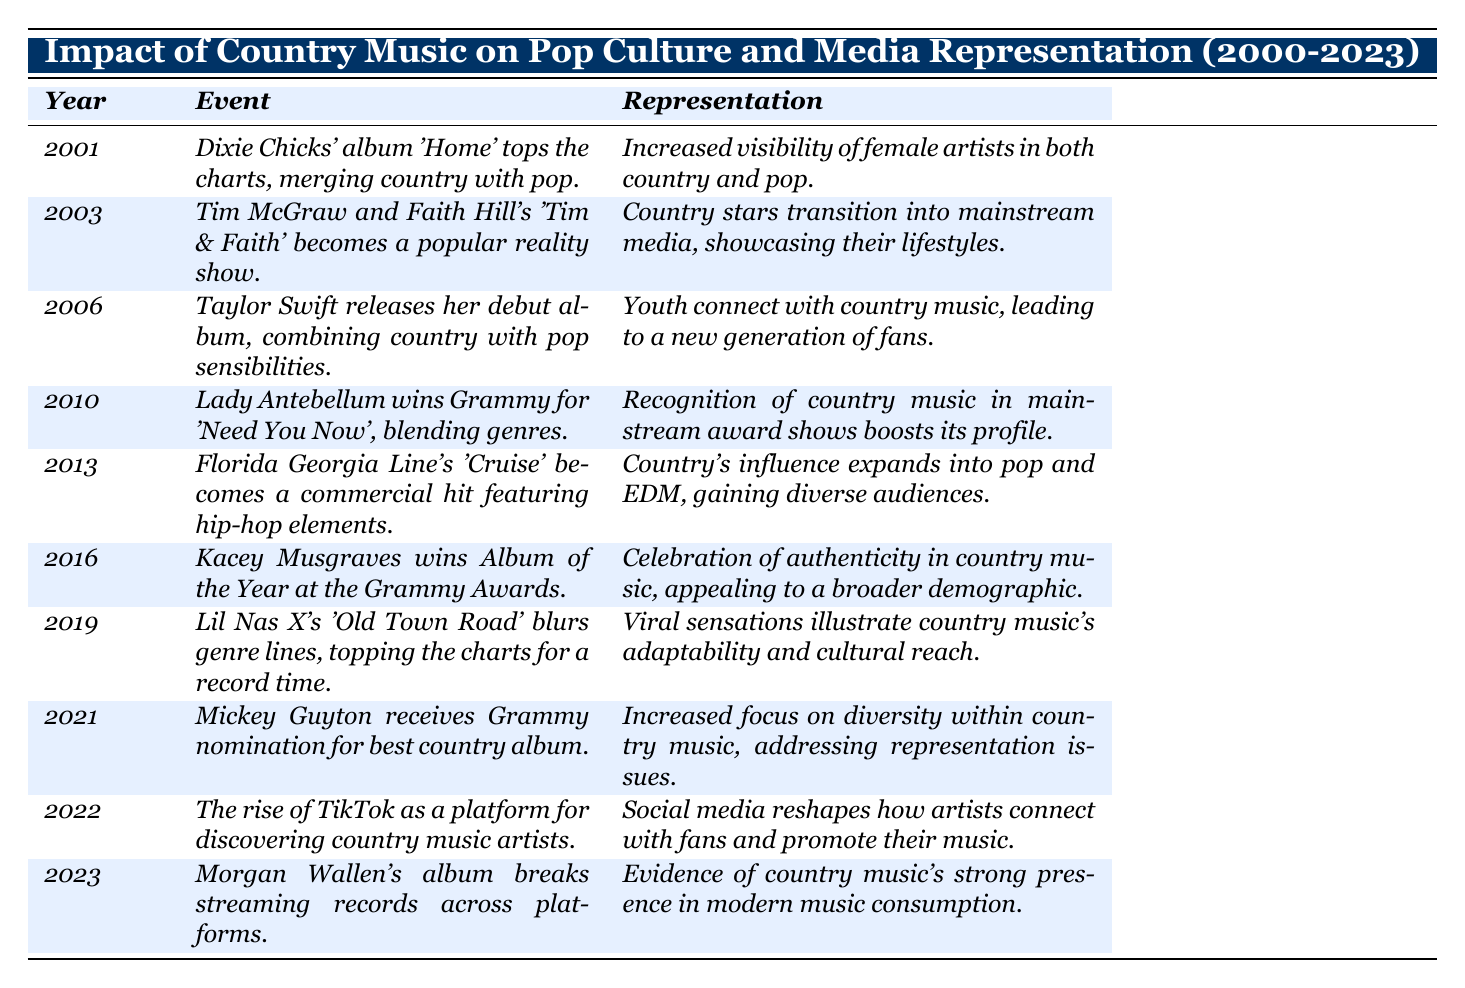What event took place in 2006? The table indicates that in 2006, Taylor Swift released her debut album, which combined country with pop sensibilities.
Answer: Taylor Swift's debut album What was a significant outcome of the 2019 event involving Lil Nas X? The event in 2019 was that Lil Nas X's 'Old Town Road' topped the charts for a record time, which illustrated the adaptability and cultural reach of country music.
Answer: Country music's adaptability and cultural reach Which artist was recognized at the Grammy Awards in 2016? According to the table, Kacey Musgraves won the Album of the Year at the Grammy Awards in 2016.
Answer: Kacey Musgraves Was there any mention of increased visibility for female artists in the years listed? Yes, the table mentions increased visibility of female artists in both country and pop due to the success of Dixie Chicks' album 'Home' in 2001.
Answer: Yes List all the years when genre-blending was highlighted in the table. The events of 2001, 2010, 2013, and 2016 mentioned blending genres, specifically noting the Dixie Chicks, Lady Antebellum, Florida Georgia Line, and Kacey Musgraves.
Answer: 2001, 2010, 2013, 2016 What trends in media representation can be seen over the years from the table? The table shows trends such as the transition of country stars into mainstream media, increased focus on diversity, and the influence of social media, particularly in 2003, 2021, and 2022 respectively.
Answer: Media representation transitioned to mainstream media and focused on diversity How many events specifically mention the influence of social media? The table mentions the rise of TikTok in 2022, which indicates the influence of social media in discovering country music artists. This is the only mention in the presented data.
Answer: One event Which year represents a milestone for diversity in country music? The year 2021 saw Mickey Guyton receiving a Grammy nomination for the best country album, representing a significant milestone for diversity in country music.
Answer: 2021 What is the average year for the listed events in the table? Adding the years and dividing by the number of years gives (2001 + 2003 + 2006 + 2010 + 2013 + 2016 + 2019 + 2021 + 2022 + 2023) / 10 = 2014.
Answer: 2014 What does the event in 2023 signify for country music's popularity? In 2023, Morgan Wallen's album breaking streaming records across platforms signifies country music's strong presence in modern music consumption.
Answer: Strong presence in modern music consumption In which year did Florida Georgia Line's 'Cruise' become a commercial hit? The table states that Florida Georgia Line's 'Cruise' became a commercial hit in 2013.
Answer: 2013 